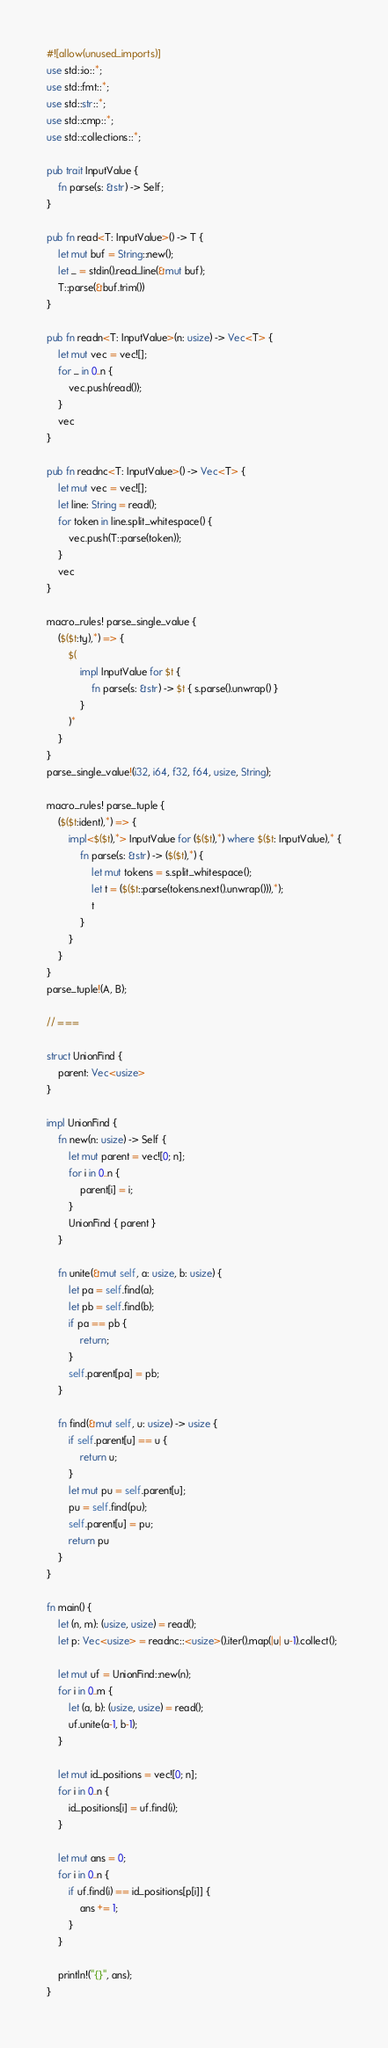Convert code to text. <code><loc_0><loc_0><loc_500><loc_500><_Rust_>#![allow(unused_imports)]
use std::io::*;
use std::fmt::*;
use std::str::*;
use std::cmp::*;
use std::collections::*;

pub trait InputValue {
    fn parse(s: &str) -> Self;
}

pub fn read<T: InputValue>() -> T {
    let mut buf = String::new();
    let _ = stdin().read_line(&mut buf);
    T::parse(&buf.trim())
}

pub fn readn<T: InputValue>(n: usize) -> Vec<T> {
    let mut vec = vec![];
    for _ in 0..n {
        vec.push(read());
    }
    vec
}

pub fn readnc<T: InputValue>() -> Vec<T> {
    let mut vec = vec![];
    let line: String = read();
    for token in line.split_whitespace() {
        vec.push(T::parse(token));
    }
    vec
}

macro_rules! parse_single_value {
    ($($t:ty),*) => {
        $(
            impl InputValue for $t {
                fn parse(s: &str) -> $t { s.parse().unwrap() }
            }
        )*
	}
}
parse_single_value!(i32, i64, f32, f64, usize, String);

macro_rules! parse_tuple {
	($($t:ident),*) => {
		impl<$($t),*> InputValue for ($($t),*) where $($t: InputValue),* {
			fn parse(s: &str) -> ($($t),*) {
				let mut tokens = s.split_whitespace();
				let t = ($($t::parse(tokens.next().unwrap())),*);
				t
			}
		}
	}
}
parse_tuple!(A, B);

// ===

struct UnionFind {
    parent: Vec<usize>
}

impl UnionFind {
    fn new(n: usize) -> Self {
        let mut parent = vec![0; n];
        for i in 0..n {
            parent[i] = i;
        }
        UnionFind { parent }
    }

    fn unite(&mut self, a: usize, b: usize) {
        let pa = self.find(a);
        let pb = self.find(b);
        if pa == pb {
            return;
        }
        self.parent[pa] = pb;
    }

    fn find(&mut self, u: usize) -> usize {
        if self.parent[u] == u {
            return u;
        }
        let mut pu = self.parent[u];
        pu = self.find(pu);
        self.parent[u] = pu;
        return pu
    }
}

fn main() {
    let (n, m): (usize, usize) = read();
    let p: Vec<usize> = readnc::<usize>().iter().map(|u| u-1).collect();

    let mut uf = UnionFind::new(n);
    for i in 0..m {
        let (a, b): (usize, usize) = read();
        uf.unite(a-1, b-1);
    }

    let mut id_positions = vec![0; n];
    for i in 0..n {
        id_positions[i] = uf.find(i);
    }

    let mut ans = 0;
    for i in 0..n {
        if uf.find(i) == id_positions[p[i]] {
            ans += 1;
        }
    }

    println!("{}", ans);
}

</code> 